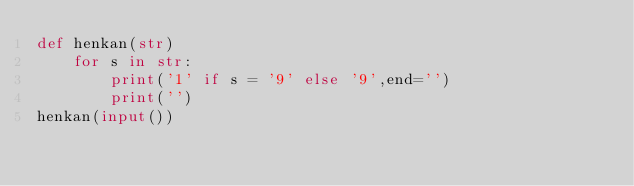<code> <loc_0><loc_0><loc_500><loc_500><_Python_>def henkan(str)
    for s in str:
        print('1' if s = '9' else '9',end='')
        print('')
henkan(input())</code> 